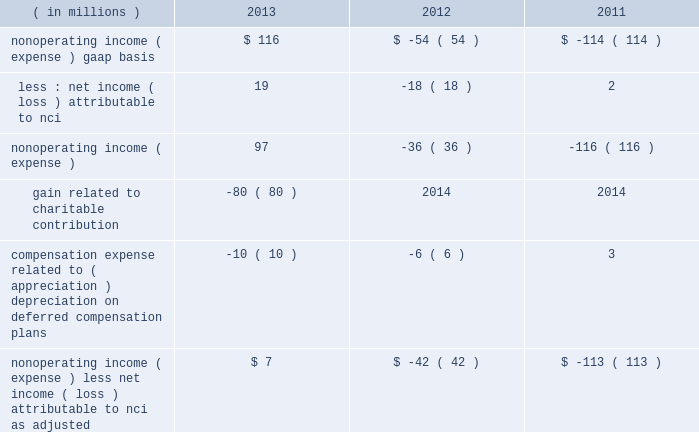Nonoperating income ( expense ) .
Blackrock also uses operating margin , as adjusted , to monitor corporate performance and efficiency and as a benchmark to compare its performance with other companies .
Management uses both gaap and non-gaap financial measures in evaluating blackrock 2019s financial performance .
The non-gaap measure by itself may pose limitations because it does not include all of blackrock 2019s revenues and expenses .
Operating income used for measuring operating margin , as adjusted , is equal to operating income , as adjusted , excluding the impact of closed-end fund launch costs and related commissions .
Management believes the exclusion of such costs and related commissions is useful because these costs can fluctuate considerably and revenues associated with the expenditure of these costs will not fully impact blackrock 2019s results until future periods .
Revenue used for operating margin , as adjusted , excludes distribution and servicing costs paid to related parties and other third parties .
Management believes the exclusion of such costs is useful because it creates consistency in the treatment for certain contracts for similar services , which due to the terms of the contracts , are accounted for under gaap on a net basis within investment advisory , administration fees and securities lending revenue .
Amortization of deferred sales commissions is excluded from revenue used for operating margin measurement , as adjusted , because such costs , over time , substantially offset distribution fee revenue the company earns .
For each of these items , blackrock excludes from revenue used for operating margin , as adjusted , the costs related to each of these items as a proxy for such offsetting revenues .
( b ) nonoperating income ( expense ) , less net income ( loss ) attributable to noncontrolling interests , as adjusted , is presented below .
The compensation expense offset is recorded in operating income .
This compensation expense has been included in nonoperating income ( expense ) , less net income ( loss ) attributable to nci , as adjusted , to offset returns on investments set aside for these plans , which are reported in nonoperating income ( expense ) , gaap basis .
Management believes nonoperating income ( expense ) , less net income ( loss ) attributable to nci , as adjusted , provides comparability of information among reporting periods and is an effective measure for reviewing blackrock 2019s nonoperating contribution to results .
As compensation expense associated with ( appreciation ) depreciation on investments related to certain deferred compensation plans , which is included in operating income , substantially offsets the gain ( loss ) on the investments set aside for these plans , management believes nonoperating income ( expense ) , less net income ( loss ) attributable to nci , as adjusted , provides a useful measure , for both management and investors , of blackrock 2019s nonoperating results that impact book value .
During 2013 , the noncash , nonoperating pre-tax gain of $ 80 million related to the contributed pennymac investment has been excluded from nonoperating income ( expense ) , less net income ( loss ) attributable to nci , as adjusted due to its nonrecurring nature and because the more than offsetting associated charitable contribution expense of $ 124 million is reported in operating income .
( in millions ) 2013 2012 2011 nonoperating income ( expense ) , gaap basis $ 116 $ ( 54 ) $ ( 114 ) less : net income ( loss ) attributable to nci 19 ( 18 ) 2 .
Gain related to charitable contribution ( 80 ) 2014 2014 compensation expense related to ( appreciation ) depreciation on deferred compensation plans ( 10 ) ( 6 ) 3 nonoperating income ( expense ) , less net income ( loss ) attributable to nci , as adjusted $ 7 $ ( 42 ) $ ( 113 ) ( c ) net income attributable to blackrock , as adjusted : management believes net income attributable to blackrock , inc. , as adjusted , and diluted earnings per common share , as adjusted , are useful measures of blackrock 2019s profitability and financial performance .
Net income attributable to blackrock , inc. , as adjusted , equals net income attributable to blackrock , inc. , gaap basis , adjusted for significant nonrecurring items , charges that ultimately will not impact blackrock 2019s book value or certain tax items that do not impact cash flow .
See note ( a ) operating income , as adjusted , and operating margin , as adjusted , for information on the pnc ltip funding obligation , merrill lynch compensation contribution , charitable contribution , u.k .
Lease exit costs , contribution to stifs and restructuring charges .
The 2013 results included a tax benefit of approximately $ 48 million recognized in connection with the charitable contribution .
The tax benefit has been excluded from net income attributable to blackrock , inc. , as adjusted due to the nonrecurring nature of the charitable contribution .
During 2013 , income tax changes included adjustments related to the revaluation of certain deferred income tax liabilities , including the effect of legislation enacted in the united kingdom and domestic state and local income tax changes .
During 2012 , income tax changes included adjustments related to the revaluation of certain deferred income tax liabilities , including the effect of legislation enacted in the united kingdom and the state and local income tax effect resulting from changes in the company 2019s organizational structure .
During 2011 , income tax changes included adjustments related to the revaluation of certain deferred income tax liabilities due to a state tax election and enacted u.k. , japan , u.s .
State and local tax legislation .
The resulting decrease in income taxes has been excluded from net income attributable to blackrock , inc. , as adjusted , as these items will not have a cash flow impact and to ensure comparability among periods presented. .
By what amount is the non-operating income gaap basis higher in 2013 compare to 2012? 
Computations: (116 - -54)
Answer: 170.0. 